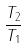<formula> <loc_0><loc_0><loc_500><loc_500>\frac { T _ { 2 } } { T _ { 1 } }</formula> 